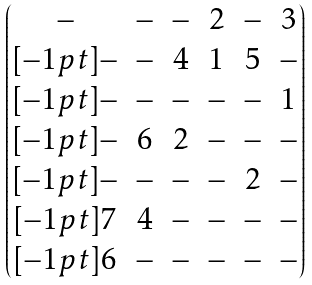Convert formula to latex. <formula><loc_0><loc_0><loc_500><loc_500>\begin{pmatrix} - & - & - & 2 & - & 3 \\ [ - 1 p t ] - & - & 4 & 1 & 5 & - \\ [ - 1 p t ] - & - & - & - & - & 1 \\ [ - 1 p t ] - & 6 & 2 & - & - & - \\ [ - 1 p t ] - & - & - & - & 2 & - \\ [ - 1 p t ] 7 & 4 & - & - & - & - \\ [ - 1 p t ] 6 & - & - & - & - & - \end{pmatrix}</formula> 